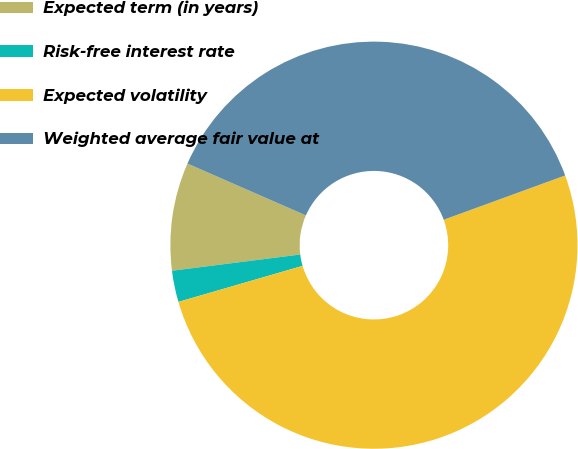<chart> <loc_0><loc_0><loc_500><loc_500><pie_chart><fcel>Expected term (in years)<fcel>Risk-free interest rate<fcel>Expected volatility<fcel>Weighted average fair value at<nl><fcel>8.57%<fcel>2.49%<fcel>51.07%<fcel>37.87%<nl></chart> 